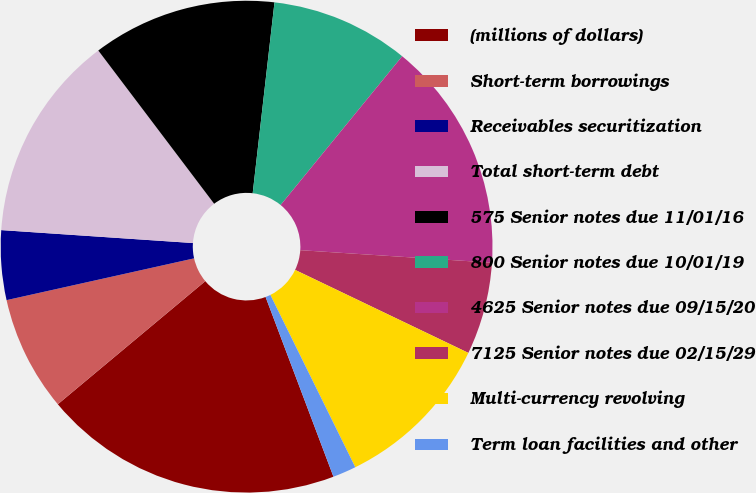Convert chart to OTSL. <chart><loc_0><loc_0><loc_500><loc_500><pie_chart><fcel>(millions of dollars)<fcel>Short-term borrowings<fcel>Receivables securitization<fcel>Total short-term debt<fcel>575 Senior notes due 11/01/16<fcel>800 Senior notes due 10/01/19<fcel>4625 Senior notes due 09/15/20<fcel>7125 Senior notes due 02/15/29<fcel>Multi-currency revolving<fcel>Term loan facilities and other<nl><fcel>19.67%<fcel>7.58%<fcel>4.56%<fcel>13.62%<fcel>12.11%<fcel>9.09%<fcel>15.13%<fcel>6.07%<fcel>10.6%<fcel>1.54%<nl></chart> 